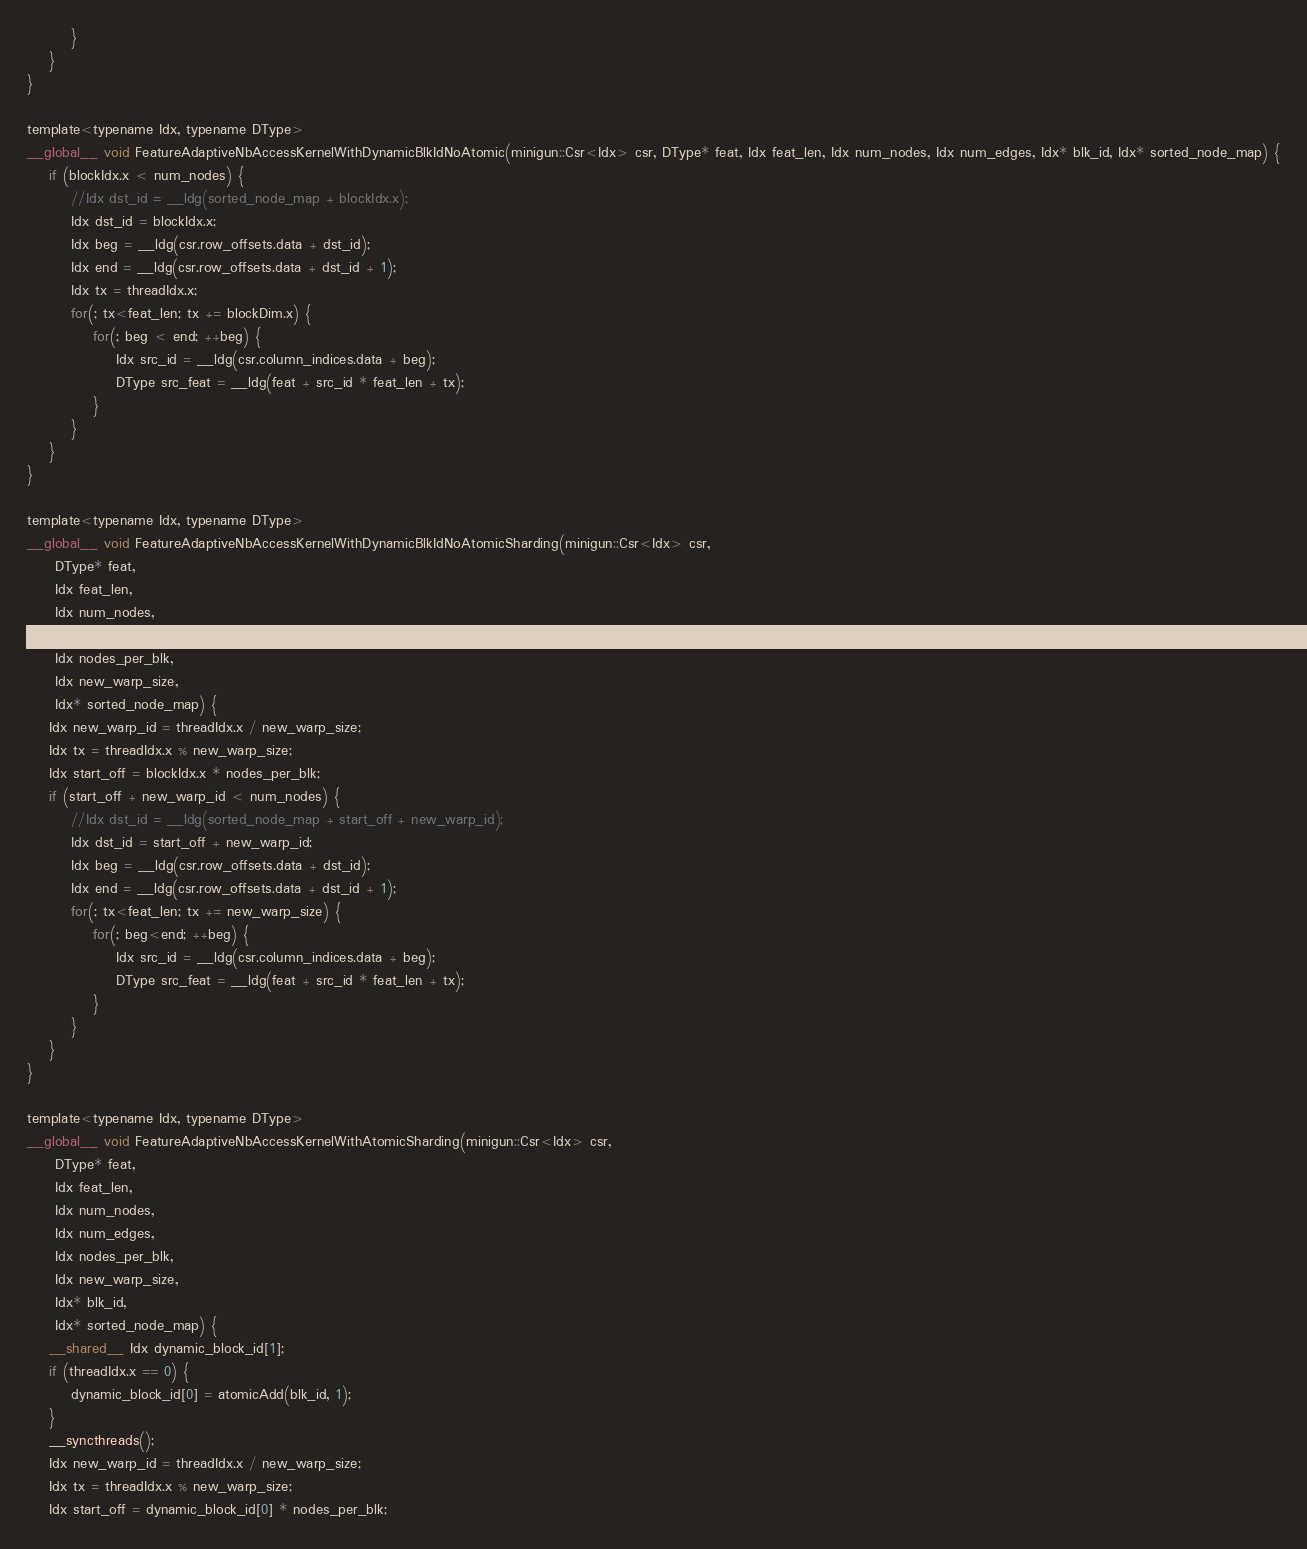<code> <loc_0><loc_0><loc_500><loc_500><_Cuda_>        }
    }
}

template<typename Idx, typename DType>
__global__ void FeatureAdaptiveNbAccessKernelWithDynamicBlkIdNoAtomic(minigun::Csr<Idx> csr, DType* feat, Idx feat_len, Idx num_nodes, Idx num_edges, Idx* blk_id, Idx* sorted_node_map) {
    if (blockIdx.x < num_nodes) {
        //Idx dst_id = __ldg(sorted_node_map + blockIdx.x);
        Idx dst_id = blockIdx.x;
        Idx beg = __ldg(csr.row_offsets.data + dst_id);
        Idx end = __ldg(csr.row_offsets.data + dst_id + 1);
        Idx tx = threadIdx.x;
        for(; tx<feat_len; tx += blockDim.x) {
            for(; beg < end; ++beg) {
                Idx src_id = __ldg(csr.column_indices.data + beg);
                DType src_feat = __ldg(feat + src_id * feat_len + tx);
            }
        }
    }
}

template<typename Idx, typename DType>
__global__ void FeatureAdaptiveNbAccessKernelWithDynamicBlkIdNoAtomicSharding(minigun::Csr<Idx> csr,
     DType* feat,
     Idx feat_len,
     Idx num_nodes,
     Idx num_edges, 
     Idx nodes_per_blk, 
     Idx new_warp_size,
     Idx* sorted_node_map) {
    Idx new_warp_id = threadIdx.x / new_warp_size; 
    Idx tx = threadIdx.x % new_warp_size;
    Idx start_off = blockIdx.x * nodes_per_blk;
    if (start_off + new_warp_id < num_nodes) {
        //Idx dst_id = __ldg(sorted_node_map + start_off + new_warp_id);
        Idx dst_id = start_off + new_warp_id;
        Idx beg = __ldg(csr.row_offsets.data + dst_id);
        Idx end = __ldg(csr.row_offsets.data + dst_id + 1);
        for(; tx<feat_len; tx += new_warp_size) {
            for(; beg<end; ++beg) {
                Idx src_id = __ldg(csr.column_indices.data + beg);
                DType src_feat = __ldg(feat + src_id * feat_len + tx);
            }
        }
    }
}

template<typename Idx, typename DType>
__global__ void FeatureAdaptiveNbAccessKernelWithAtomicSharding(minigun::Csr<Idx> csr,
     DType* feat,
     Idx feat_len,
     Idx num_nodes,
     Idx num_edges, 
     Idx nodes_per_blk, 
     Idx new_warp_size,
     Idx* blk_id,
     Idx* sorted_node_map) {
    __shared__ Idx dynamic_block_id[1];
    if (threadIdx.x == 0) {
        dynamic_block_id[0] = atomicAdd(blk_id, 1);
    }
    __syncthreads();
    Idx new_warp_id = threadIdx.x / new_warp_size; 
    Idx tx = threadIdx.x % new_warp_size;
    Idx start_off = dynamic_block_id[0] * nodes_per_blk;</code> 